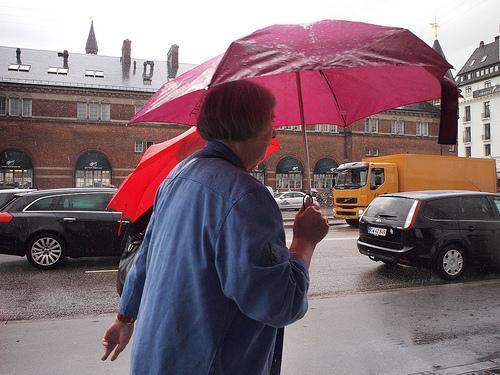How many people can be seen?
Give a very brief answer. 2. How many umbrellas are there?
Give a very brief answer. 2. How many trucks are there?
Give a very brief answer. 1. How many black cars are there?
Give a very brief answer. 2. 